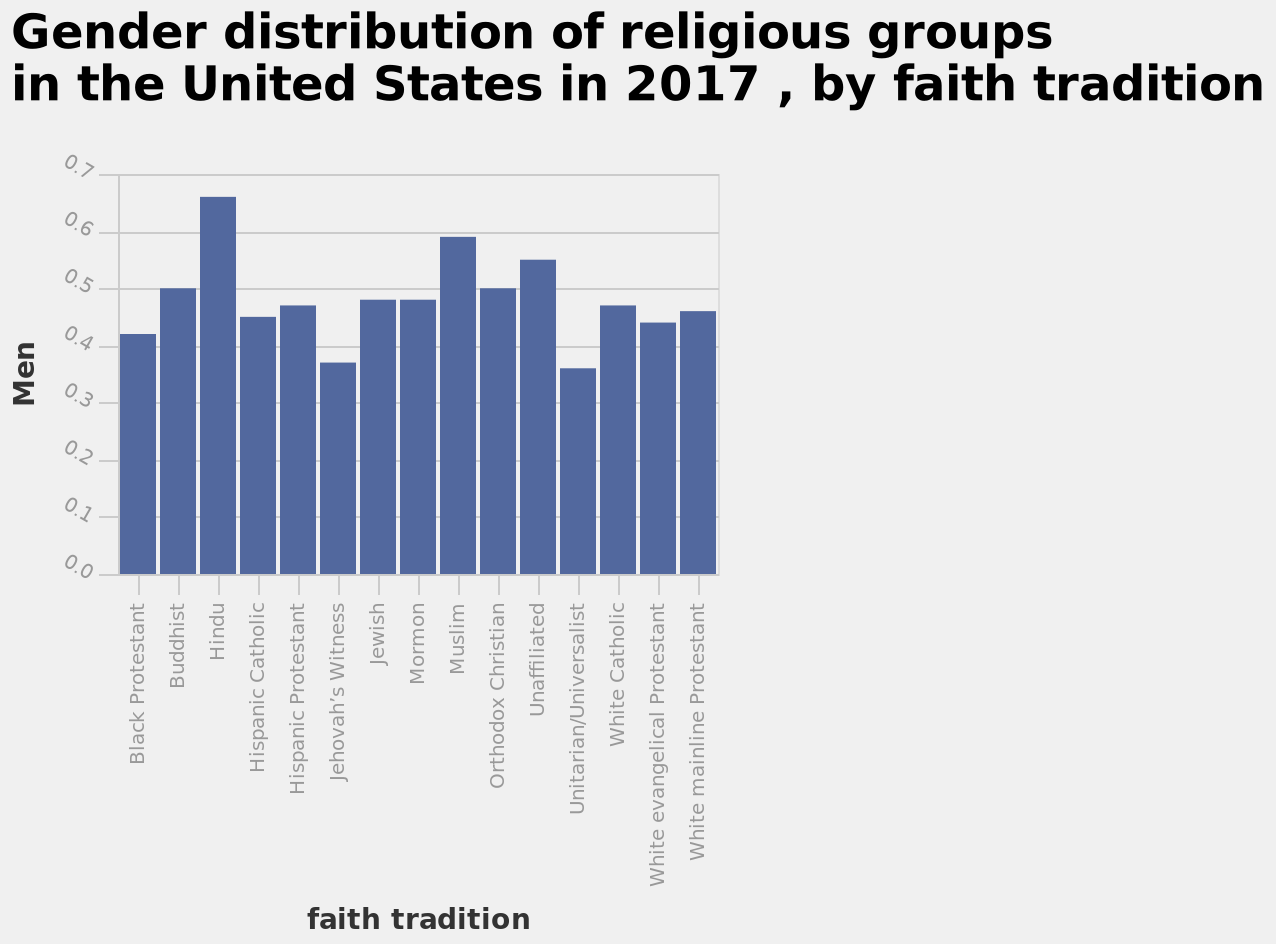<image>
Which religions have the highest percentage of men according to the bar chart?  Hinduism and Islam have the highest percentage of men. Which religious group has the highest number of men according to the bar graph? According to the bar graph, the religious group with the highest number of men is not specified in the given information. please summary the statistics and relations of the chart from studying this bar chart, I can see that Hinduism and Islam has the highest percentage of men with unaffiliated being third in place. it seems Jehovahs whiteness is lowest in percentage of men. What is the ranking of religions in terms of the percentage of men, from highest to lowest? Hinduism and Islam have the highest percentage of men, followed by unaffiliated, and Jehovah's Whiteness has the lowest percentage. What is the third highest religion in terms of the percentage of men? Unaffiliated is the third highest religion in terms of the percentage of men. please enumerates aspects of the construction of the chart Gender distribution of religious groups in the United States in 2017 , by faith tradition is a bar graph. The y-axis shows Men. Along the x-axis, faith tradition is shown as a categorical scale with Black Protestant on one end and White mainline Protestant at the other. 